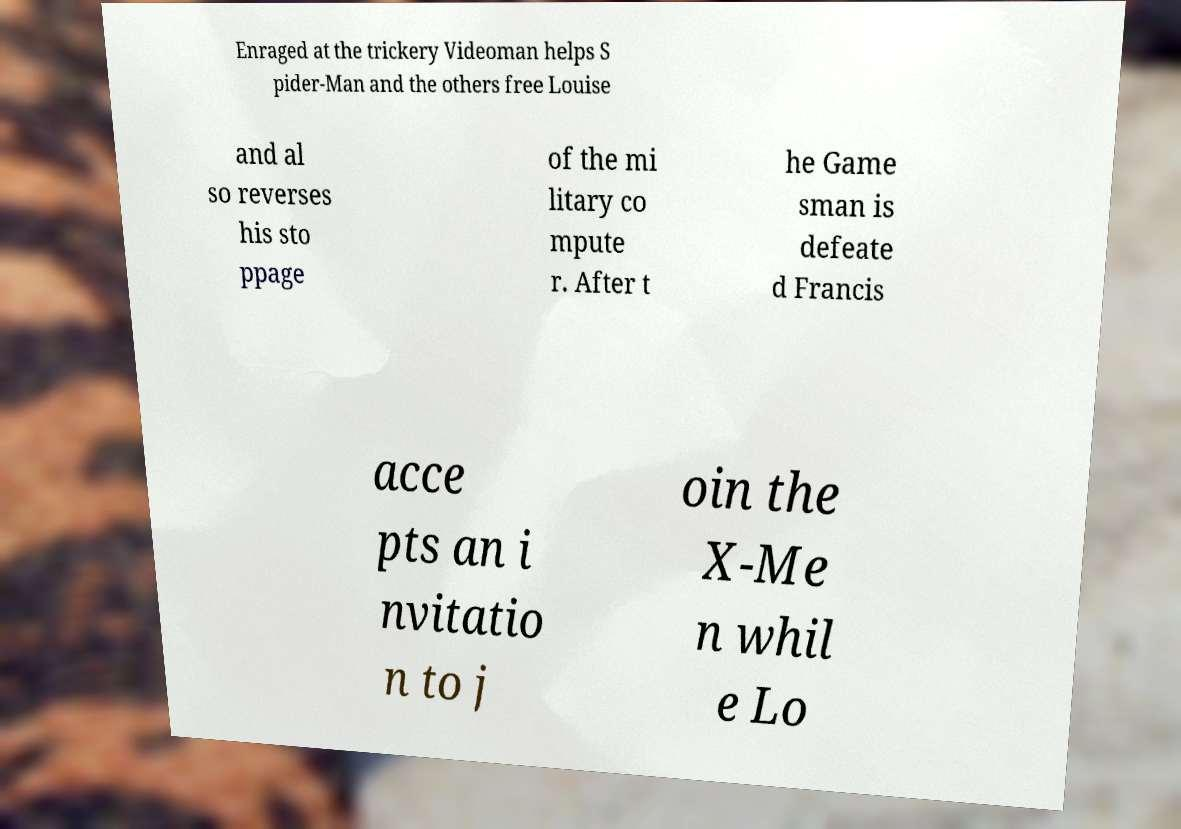For documentation purposes, I need the text within this image transcribed. Could you provide that? Enraged at the trickery Videoman helps S pider-Man and the others free Louise and al so reverses his sto ppage of the mi litary co mpute r. After t he Game sman is defeate d Francis acce pts an i nvitatio n to j oin the X-Me n whil e Lo 